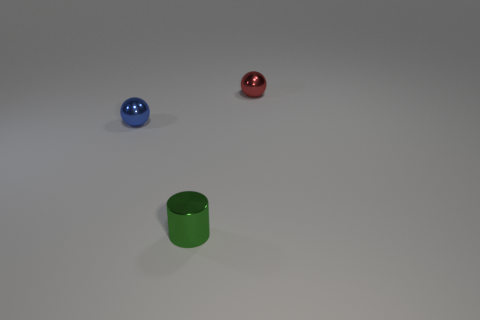There is another tiny thing that is the same shape as the blue object; what is its color?
Keep it short and to the point. Red. Is there anything else that has the same shape as the blue metallic object?
Provide a short and direct response. Yes. How many blocks are big purple objects or metallic objects?
Provide a succinct answer. 0. What shape is the tiny red metallic thing?
Give a very brief answer. Sphere. There is a red metal ball; are there any shiny cylinders to the right of it?
Provide a succinct answer. No. Are the tiny red sphere and the tiny thing in front of the blue object made of the same material?
Make the answer very short. Yes. There is a metal object that is in front of the blue thing; is its shape the same as the tiny red object?
Your answer should be compact. No. What number of things are made of the same material as the red sphere?
Provide a succinct answer. 2. What number of objects are objects left of the red object or small shiny balls?
Provide a short and direct response. 3. What size is the cylinder?
Make the answer very short. Small. 